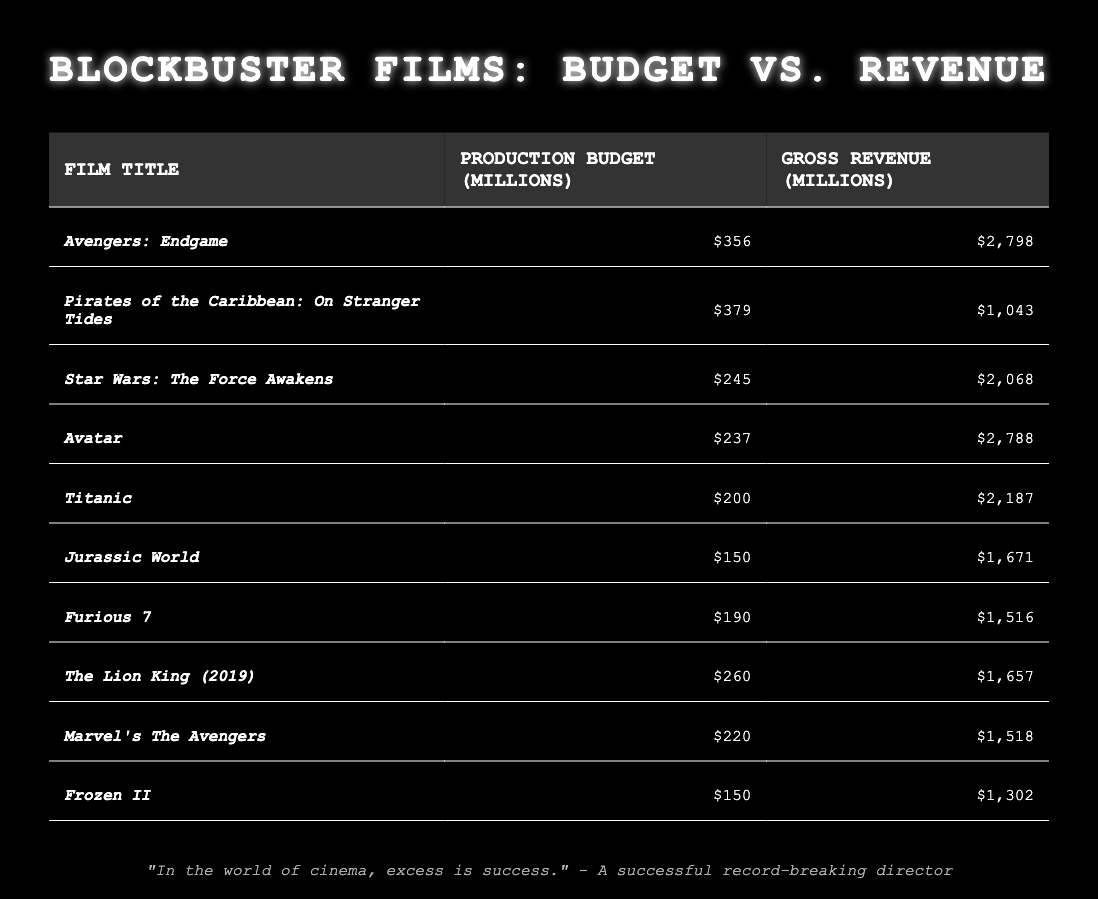What is the production budget of "Furious 7"? The table lists the production budget of "Furious 7" under the "Production Budget (Millions)" column, which shows 190 million.
Answer: 190 million Which film has the highest gross revenue? To find the answer, we look at the "Gross Revenue (Millions)" column and identify the highest value, which is 2798 million for "Avengers: Endgame."
Answer: Avengers: Endgame How much more did "Avatar" earn compared to "Jurassic World"? To find the difference, we subtract the gross revenue of "Jurassic World" (1671 million) from "Avatar" (2788 million): 2788 - 1671 = 1117 million.
Answer: 1117 million What is the average production budget of the films listed? The total production budget is the sum of all production budgets: (356 + 379 + 245 + 237 + 200 + 150 + 190 + 260 + 220 + 150) = 1987 million. There are 10 films, so the average is 1987/10 = 198.7 million.
Answer: 198.7 million Is the gross revenue of "Frozen II" greater than its production budget? We compare the values from the table: "Frozen II" has a production budget of 150 million and gross revenue of 1302 million. Since 1302 million is greater than 150 million, the answer is yes.
Answer: Yes What is the total gross revenue of the films with a production budget above 250 million? First, identify the films with budgets above 250 million: "Avengers: Endgame" (2798 million), "Pirates of the Caribbean: On Stranger Tides" (1043 million), and "The Lion King (2019)" (1657 million). Their gross revenues are added: 2798 + 1043 + 1657 = 4498 million.
Answer: 4498 million Which film has the lowest gross revenue and what is that amount? To find the film with the lowest gross revenue, we look down the "Gross Revenue (Millions)" column for the smallest number, which is 1043 million for "Pirates of the Caribbean: On Stranger Tides."
Answer: Pirates of the Caribbean: On Stranger Tides, 1043 million What is the difference between the production budgets of "Titanic" and "Avatar"? We take the production budget of "Titanic" (200 million) and subtract it from "Avatar" (237 million): 237 - 200 = 37 million.
Answer: 37 million Are there any films listed with a gross revenue of less than 1 billion? No film in the table has a gross revenue less than 1 billion; all of them exceed this value.
Answer: No What percentage does "Jurassic World" represent of the total gross revenue? First, find the total gross revenue by summing all values: (2798 + 1043 + 2068 + 2788 + 2187 + 1671 + 1516 + 1657 + 1518 + 1302) = 13,238 million. "Jurassic World" has a gross revenue of 1671 million. The percentage is calculated as (1671/13238) * 100 ≈ 12.6%.
Answer: Approximately 12.6% 